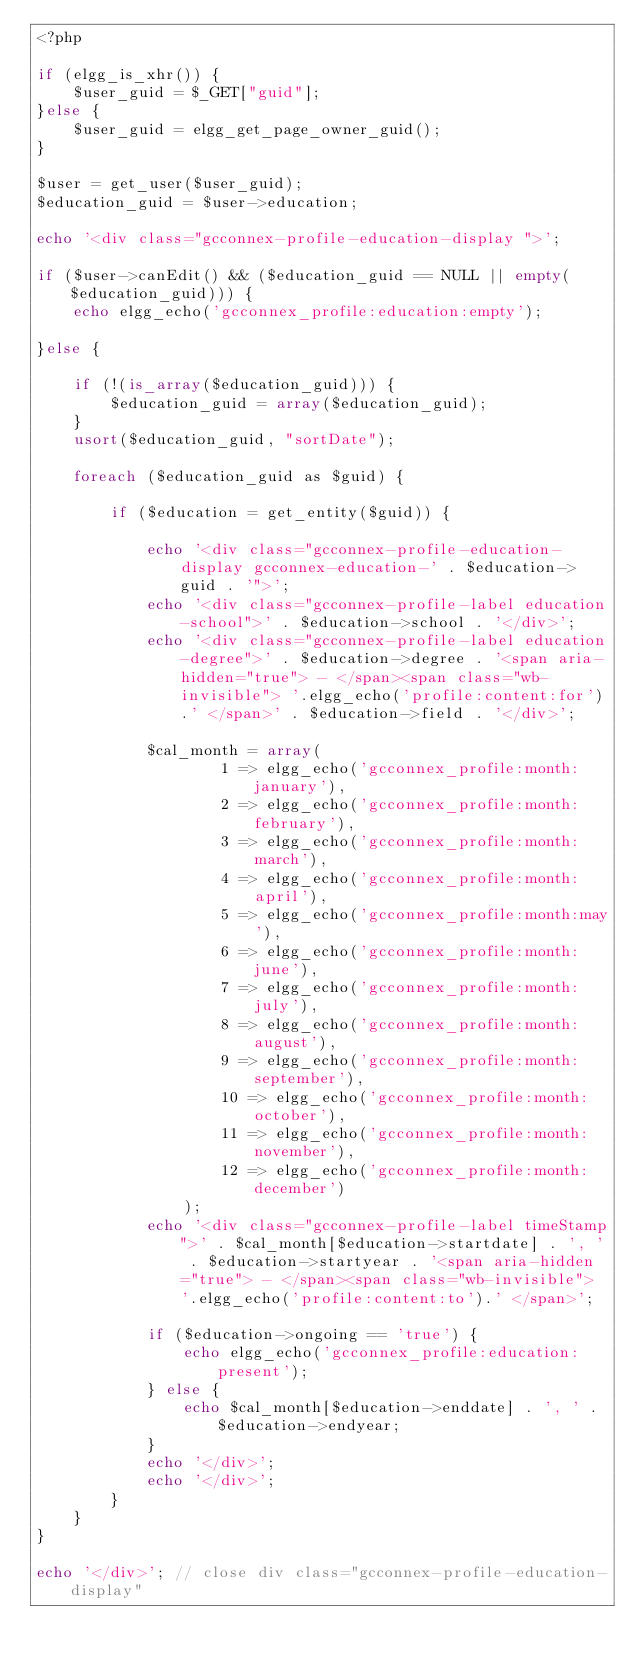<code> <loc_0><loc_0><loc_500><loc_500><_PHP_><?php

if (elgg_is_xhr()) {
    $user_guid = $_GET["guid"];
}else {
    $user_guid = elgg_get_page_owner_guid();
}

$user = get_user($user_guid);
$education_guid = $user->education;

echo '<div class="gcconnex-profile-education-display ">';

if ($user->canEdit() && ($education_guid == NULL || empty($education_guid))) {
    echo elgg_echo('gcconnex_profile:education:empty');

}else {

    if (!(is_array($education_guid))) {
        $education_guid = array($education_guid);
    }
    usort($education_guid, "sortDate");

    foreach ($education_guid as $guid) {

        if ($education = get_entity($guid)) {

            echo '<div class="gcconnex-profile-education-display gcconnex-education-' . $education->guid . '">';
            echo '<div class="gcconnex-profile-label education-school">' . $education->school . '</div>';
            echo '<div class="gcconnex-profile-label education-degree">' . $education->degree . '<span aria-hidden="true"> - </span><span class="wb-invisible"> '.elgg_echo('profile:content:for').' </span>' . $education->field . '</div>';

            $cal_month = array(
                    1 => elgg_echo('gcconnex_profile:month:january'),
                    2 => elgg_echo('gcconnex_profile:month:february'),
                    3 => elgg_echo('gcconnex_profile:month:march'),
                    4 => elgg_echo('gcconnex_profile:month:april'),
                    5 => elgg_echo('gcconnex_profile:month:may'),
                    6 => elgg_echo('gcconnex_profile:month:june'),
                    7 => elgg_echo('gcconnex_profile:month:july'),
                    8 => elgg_echo('gcconnex_profile:month:august'),
                    9 => elgg_echo('gcconnex_profile:month:september'),
                    10 => elgg_echo('gcconnex_profile:month:october'),
                    11 => elgg_echo('gcconnex_profile:month:november'),
                    12 => elgg_echo('gcconnex_profile:month:december')
                );
            echo '<div class="gcconnex-profile-label timeStamp">' . $cal_month[$education->startdate] . ', ' . $education->startyear . '<span aria-hidden="true"> - </span><span class="wb-invisible"> '.elgg_echo('profile:content:to').' </span>';

            if ($education->ongoing == 'true') {
                echo elgg_echo('gcconnex_profile:education:present');
            } else {
                echo $cal_month[$education->enddate] . ', ' . $education->endyear;
            }
            echo '</div>';
            echo '</div>';
        }
    }
}

echo '</div>'; // close div class="gcconnex-profile-education-display"
</code> 